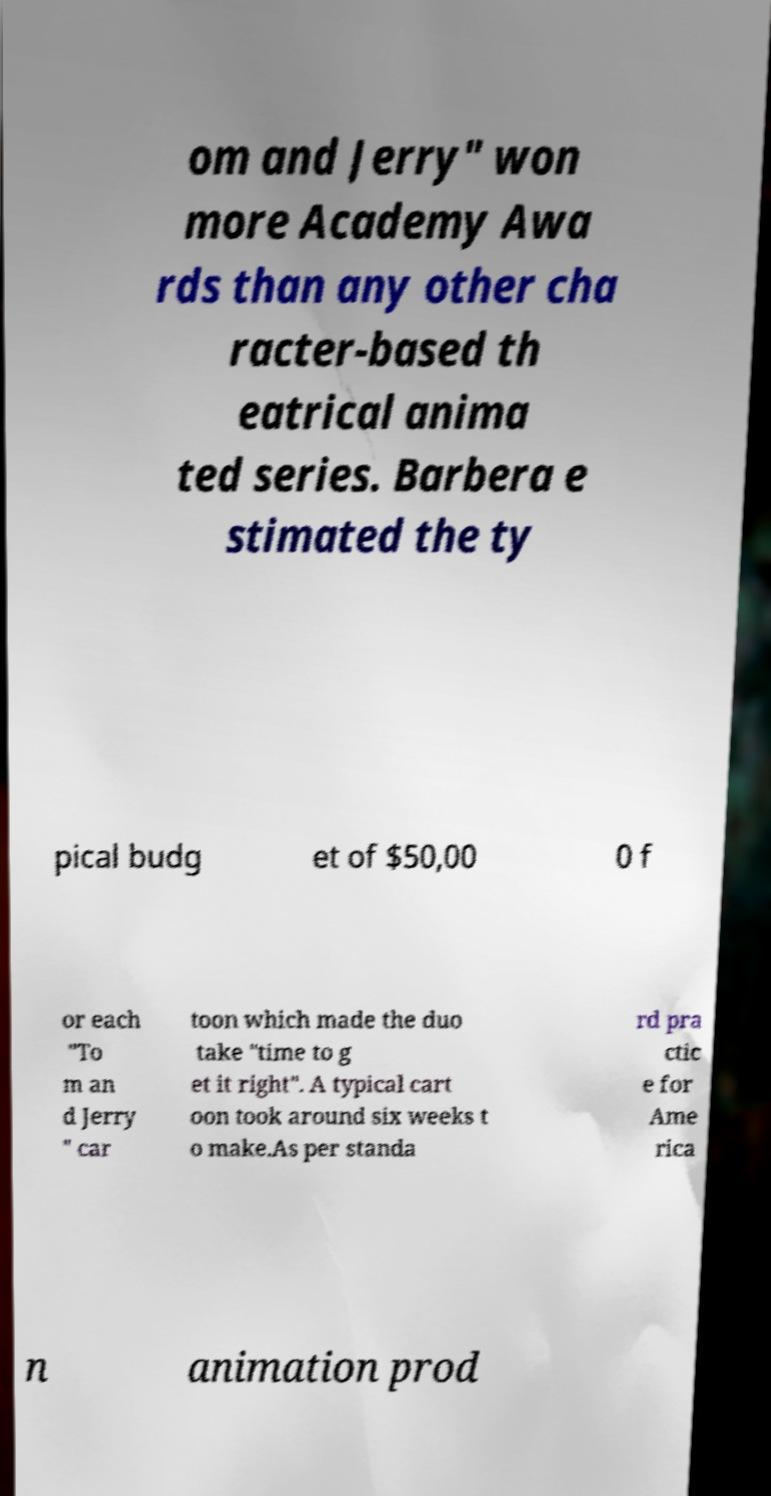Could you assist in decoding the text presented in this image and type it out clearly? om and Jerry" won more Academy Awa rds than any other cha racter-based th eatrical anima ted series. Barbera e stimated the ty pical budg et of $50,00 0 f or each "To m an d Jerry " car toon which made the duo take "time to g et it right". A typical cart oon took around six weeks t o make.As per standa rd pra ctic e for Ame rica n animation prod 